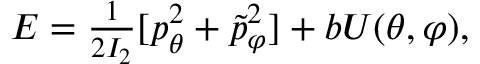<formula> <loc_0><loc_0><loc_500><loc_500>\begin{array} { r } { E = \frac { 1 } { 2 I _ { 2 } } [ p _ { \theta } ^ { 2 } + \tilde { p } _ { \varphi } ^ { 2 } ] + b U ( \theta , \varphi ) , } \end{array}</formula> 